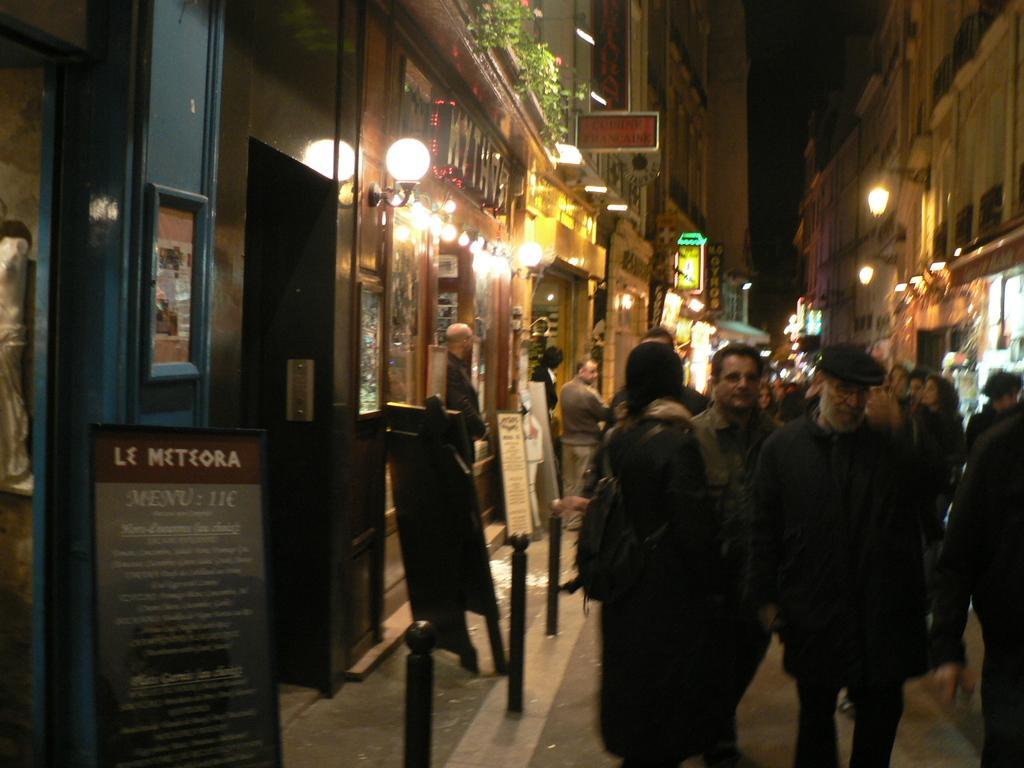Please provide a concise description of this image. In this picture we can see few people are standing on the path. There are some boards on the path. We can see few lights on the buildings which are on the left and right side. Some plants and few boards are visible on the building. 